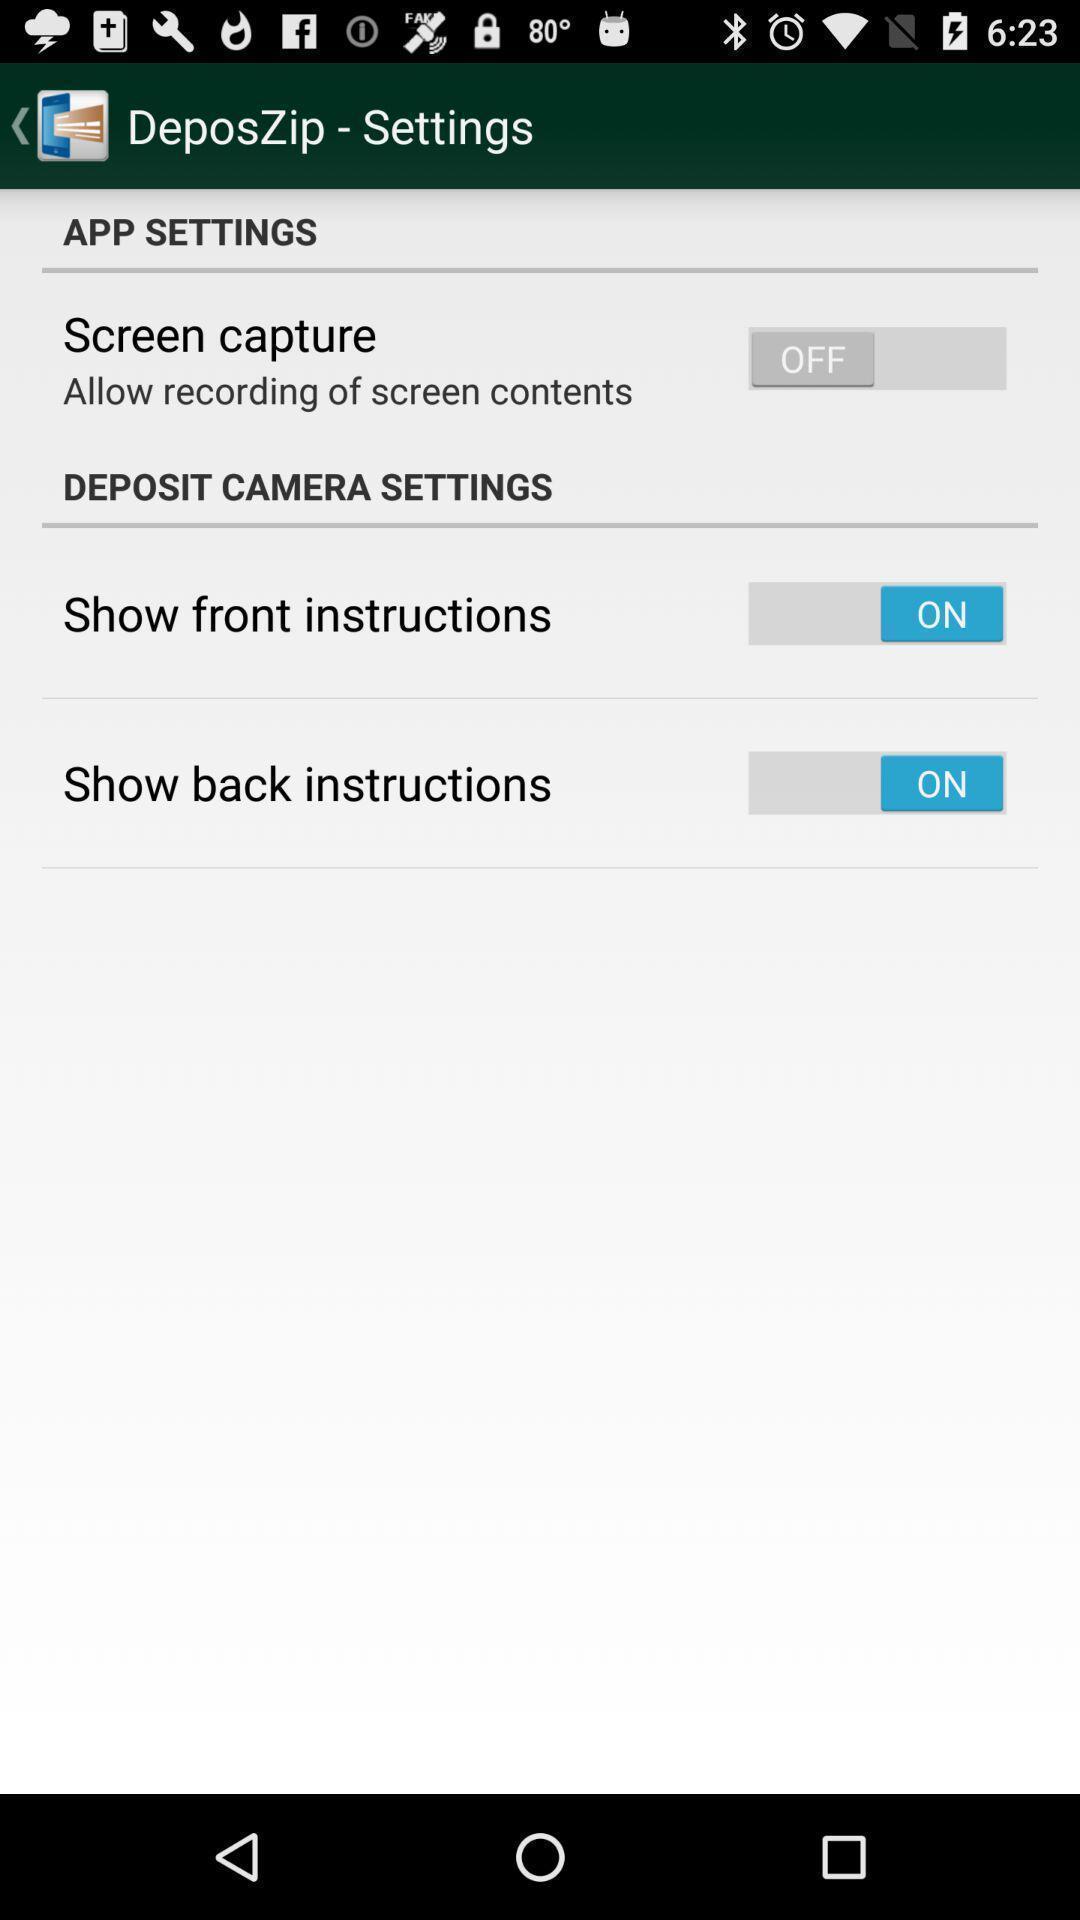What details can you identify in this image? Showing settings page. 